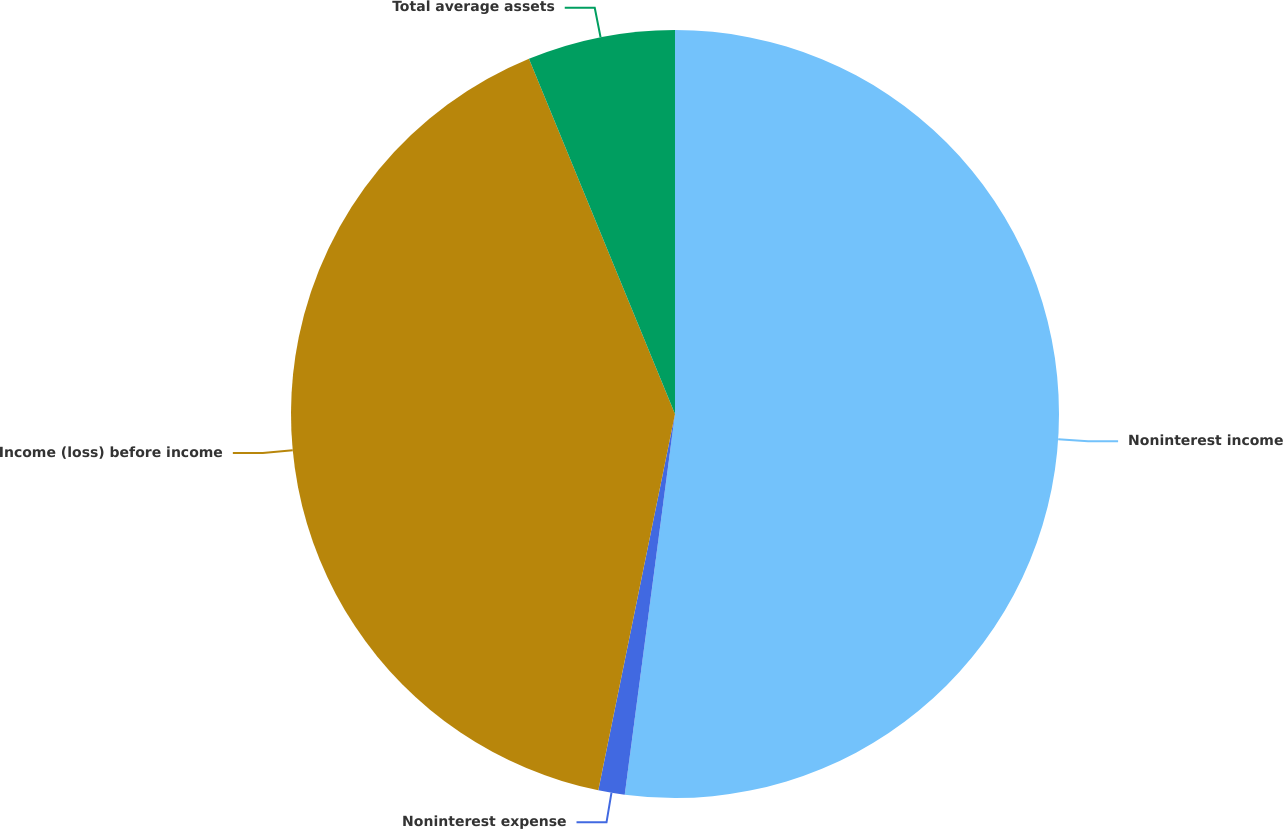Convert chart to OTSL. <chart><loc_0><loc_0><loc_500><loc_500><pie_chart><fcel>Noninterest income<fcel>Noninterest expense<fcel>Income (loss) before income<fcel>Total average assets<nl><fcel>52.09%<fcel>1.11%<fcel>40.59%<fcel>6.21%<nl></chart> 